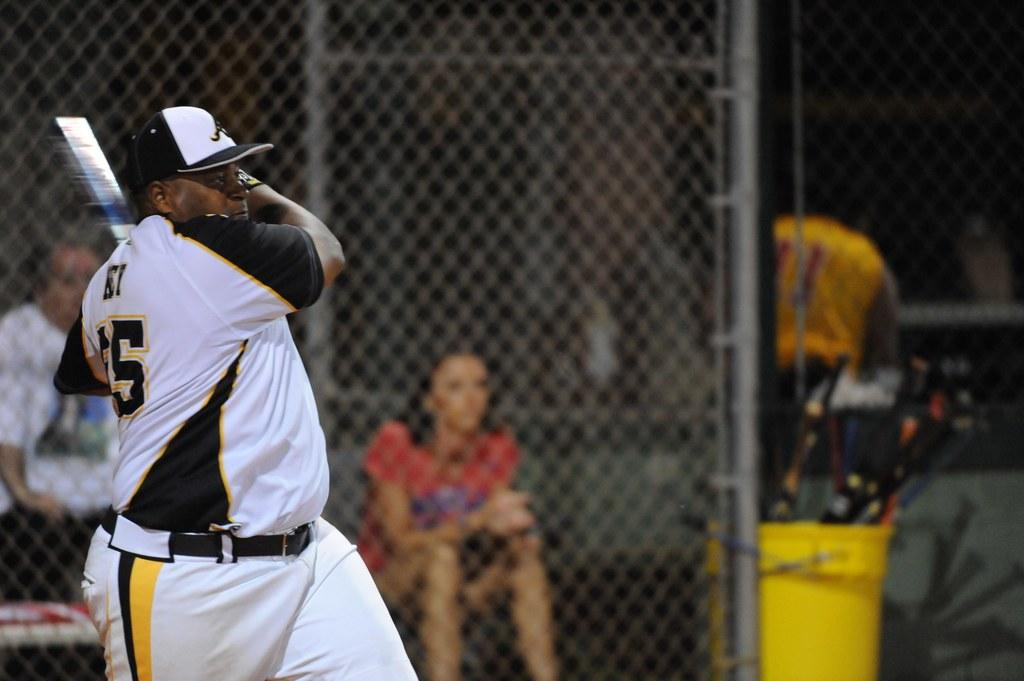<image>
Render a clear and concise summary of the photo. A woman sits in a dugout while a man with the number 5 on his jersey hits a ball. 